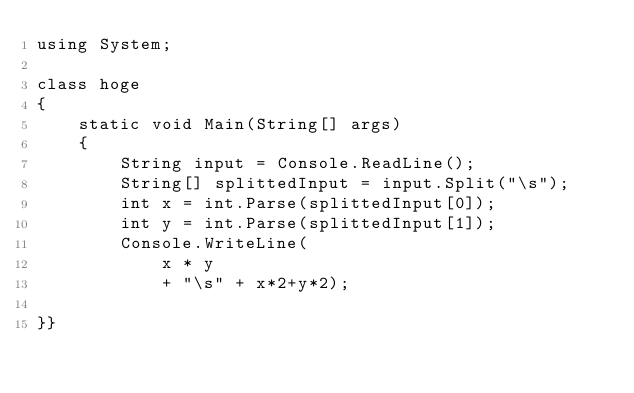Convert code to text. <code><loc_0><loc_0><loc_500><loc_500><_C#_>using System;
 
class hoge
{
    static void Main(String[] args)
    {
        String input = Console.ReadLine();
        String[] splittedInput = input.Split("\s");
        int x = int.Parse(splittedInput[0]);
        int y = int.Parse(splittedInput[1]);
        Console.WriteLine(
            x * y
            + "\s" + x*2+y*2);
 
}}</code> 